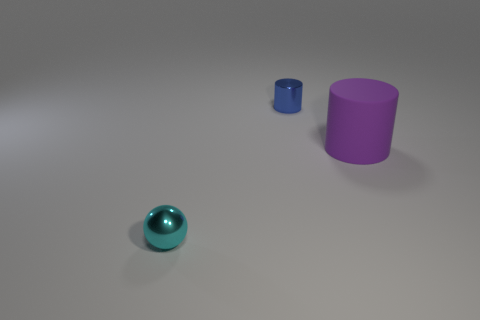Is there anything else that has the same material as the big cylinder?
Give a very brief answer. No. What number of small objects are blue shiny cylinders or cyan spheres?
Offer a very short reply. 2. What size is the other thing that is the same shape as the large matte object?
Provide a succinct answer. Small. Is there anything else that is the same size as the matte object?
Ensure brevity in your answer.  No. What material is the small object that is to the left of the blue metallic thing that is behind the large cylinder?
Ensure brevity in your answer.  Metal. How many metallic things are large blue cubes or small objects?
Offer a very short reply. 2. What is the color of the small thing that is the same shape as the large object?
Ensure brevity in your answer.  Blue. There is a tiny object in front of the small blue metallic thing; is there a blue cylinder that is right of it?
Provide a succinct answer. Yes. How many objects are both left of the matte thing and to the right of the cyan thing?
Make the answer very short. 1. What number of big purple things have the same material as the cyan sphere?
Your answer should be compact. 0. 